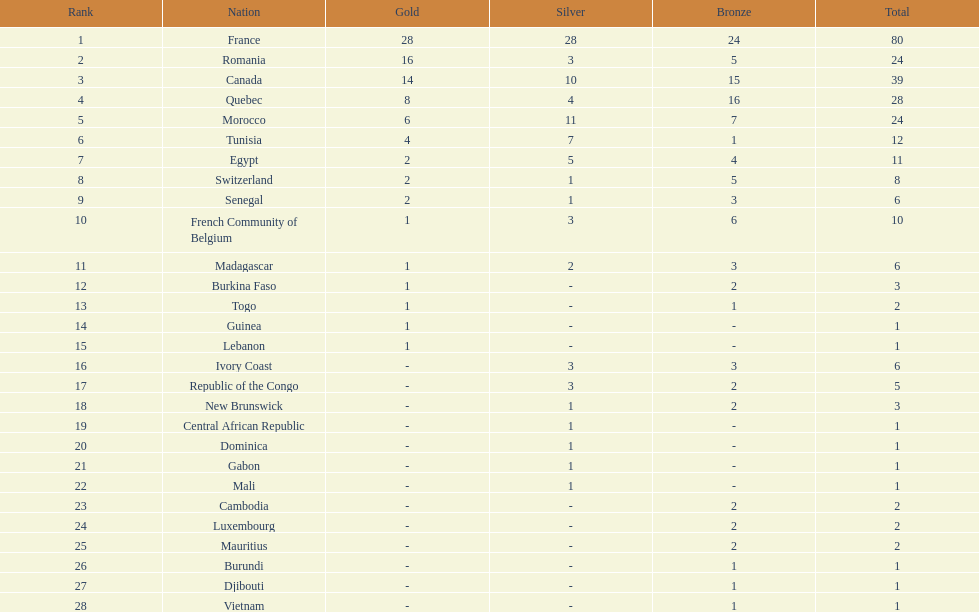What is the cumulative medal tally for switzerland? 8. 